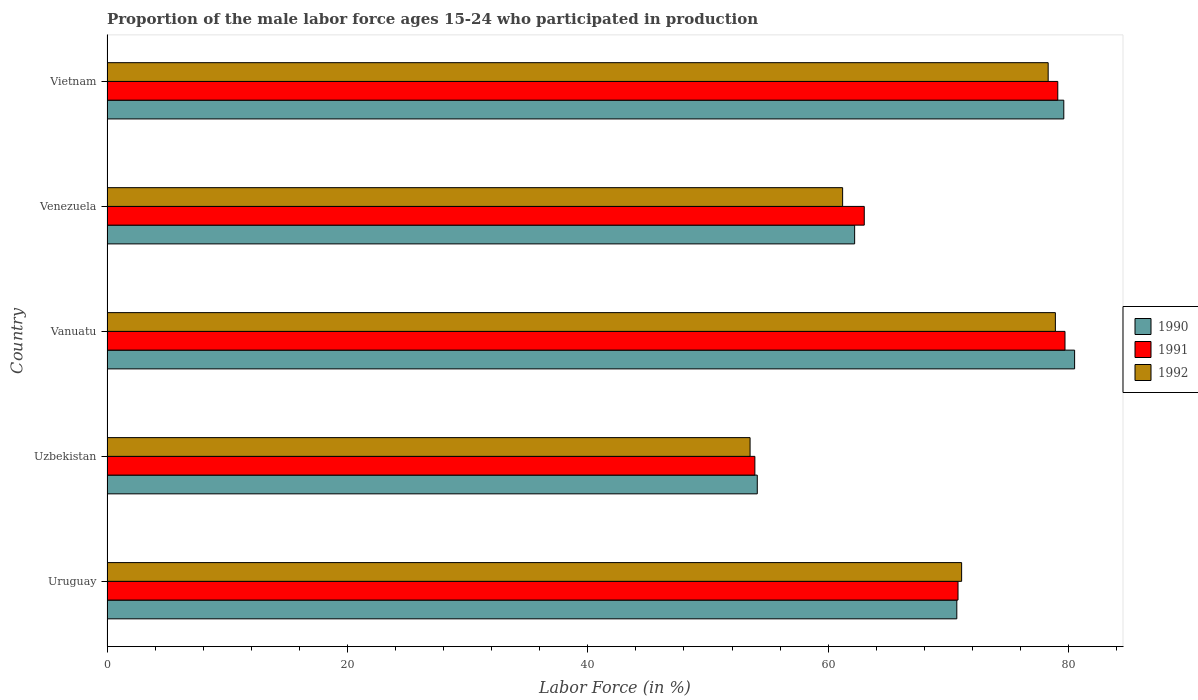Are the number of bars per tick equal to the number of legend labels?
Keep it short and to the point. Yes. Are the number of bars on each tick of the Y-axis equal?
Provide a short and direct response. Yes. How many bars are there on the 5th tick from the top?
Provide a short and direct response. 3. How many bars are there on the 2nd tick from the bottom?
Give a very brief answer. 3. What is the label of the 2nd group of bars from the top?
Ensure brevity in your answer.  Venezuela. What is the proportion of the male labor force who participated in production in 1990 in Venezuela?
Your answer should be compact. 62.2. Across all countries, what is the maximum proportion of the male labor force who participated in production in 1990?
Provide a succinct answer. 80.5. Across all countries, what is the minimum proportion of the male labor force who participated in production in 1991?
Offer a terse response. 53.9. In which country was the proportion of the male labor force who participated in production in 1992 maximum?
Provide a short and direct response. Vanuatu. In which country was the proportion of the male labor force who participated in production in 1990 minimum?
Offer a terse response. Uzbekistan. What is the total proportion of the male labor force who participated in production in 1991 in the graph?
Keep it short and to the point. 346.5. What is the difference between the proportion of the male labor force who participated in production in 1991 in Uruguay and that in Vietnam?
Give a very brief answer. -8.3. What is the difference between the proportion of the male labor force who participated in production in 1992 in Uzbekistan and the proportion of the male labor force who participated in production in 1990 in Venezuela?
Your answer should be very brief. -8.7. What is the average proportion of the male labor force who participated in production in 1991 per country?
Your answer should be compact. 69.3. What is the difference between the proportion of the male labor force who participated in production in 1991 and proportion of the male labor force who participated in production in 1992 in Uzbekistan?
Provide a succinct answer. 0.4. What is the ratio of the proportion of the male labor force who participated in production in 1992 in Vanuatu to that in Vietnam?
Your answer should be compact. 1.01. Is the proportion of the male labor force who participated in production in 1992 in Uruguay less than that in Venezuela?
Offer a very short reply. No. Is the difference between the proportion of the male labor force who participated in production in 1991 in Uruguay and Vanuatu greater than the difference between the proportion of the male labor force who participated in production in 1992 in Uruguay and Vanuatu?
Make the answer very short. No. What is the difference between the highest and the second highest proportion of the male labor force who participated in production in 1990?
Provide a short and direct response. 0.9. What is the difference between the highest and the lowest proportion of the male labor force who participated in production in 1990?
Make the answer very short. 26.4. In how many countries, is the proportion of the male labor force who participated in production in 1991 greater than the average proportion of the male labor force who participated in production in 1991 taken over all countries?
Give a very brief answer. 3. What does the 3rd bar from the top in Uruguay represents?
Your answer should be compact. 1990. What does the 1st bar from the bottom in Uzbekistan represents?
Provide a succinct answer. 1990. Is it the case that in every country, the sum of the proportion of the male labor force who participated in production in 1991 and proportion of the male labor force who participated in production in 1990 is greater than the proportion of the male labor force who participated in production in 1992?
Provide a succinct answer. Yes. What is the difference between two consecutive major ticks on the X-axis?
Offer a terse response. 20. Are the values on the major ticks of X-axis written in scientific E-notation?
Keep it short and to the point. No. How many legend labels are there?
Your answer should be compact. 3. What is the title of the graph?
Your answer should be very brief. Proportion of the male labor force ages 15-24 who participated in production. What is the label or title of the X-axis?
Offer a very short reply. Labor Force (in %). What is the label or title of the Y-axis?
Provide a succinct answer. Country. What is the Labor Force (in %) of 1990 in Uruguay?
Provide a short and direct response. 70.7. What is the Labor Force (in %) in 1991 in Uruguay?
Give a very brief answer. 70.8. What is the Labor Force (in %) of 1992 in Uruguay?
Your answer should be compact. 71.1. What is the Labor Force (in %) in 1990 in Uzbekistan?
Ensure brevity in your answer.  54.1. What is the Labor Force (in %) in 1991 in Uzbekistan?
Make the answer very short. 53.9. What is the Labor Force (in %) of 1992 in Uzbekistan?
Your answer should be very brief. 53.5. What is the Labor Force (in %) in 1990 in Vanuatu?
Provide a succinct answer. 80.5. What is the Labor Force (in %) of 1991 in Vanuatu?
Provide a succinct answer. 79.7. What is the Labor Force (in %) of 1992 in Vanuatu?
Keep it short and to the point. 78.9. What is the Labor Force (in %) in 1990 in Venezuela?
Your answer should be very brief. 62.2. What is the Labor Force (in %) in 1992 in Venezuela?
Make the answer very short. 61.2. What is the Labor Force (in %) in 1990 in Vietnam?
Give a very brief answer. 79.6. What is the Labor Force (in %) of 1991 in Vietnam?
Make the answer very short. 79.1. What is the Labor Force (in %) of 1992 in Vietnam?
Your answer should be very brief. 78.3. Across all countries, what is the maximum Labor Force (in %) of 1990?
Your answer should be compact. 80.5. Across all countries, what is the maximum Labor Force (in %) of 1991?
Your answer should be very brief. 79.7. Across all countries, what is the maximum Labor Force (in %) of 1992?
Provide a succinct answer. 78.9. Across all countries, what is the minimum Labor Force (in %) of 1990?
Make the answer very short. 54.1. Across all countries, what is the minimum Labor Force (in %) of 1991?
Make the answer very short. 53.9. Across all countries, what is the minimum Labor Force (in %) of 1992?
Ensure brevity in your answer.  53.5. What is the total Labor Force (in %) in 1990 in the graph?
Make the answer very short. 347.1. What is the total Labor Force (in %) of 1991 in the graph?
Make the answer very short. 346.5. What is the total Labor Force (in %) of 1992 in the graph?
Offer a terse response. 343. What is the difference between the Labor Force (in %) in 1991 in Uruguay and that in Uzbekistan?
Offer a terse response. 16.9. What is the difference between the Labor Force (in %) in 1992 in Uruguay and that in Uzbekistan?
Provide a short and direct response. 17.6. What is the difference between the Labor Force (in %) in 1991 in Uruguay and that in Vanuatu?
Provide a short and direct response. -8.9. What is the difference between the Labor Force (in %) of 1990 in Uruguay and that in Venezuela?
Give a very brief answer. 8.5. What is the difference between the Labor Force (in %) of 1991 in Uruguay and that in Venezuela?
Provide a succinct answer. 7.8. What is the difference between the Labor Force (in %) of 1992 in Uruguay and that in Venezuela?
Provide a short and direct response. 9.9. What is the difference between the Labor Force (in %) in 1992 in Uruguay and that in Vietnam?
Your answer should be compact. -7.2. What is the difference between the Labor Force (in %) in 1990 in Uzbekistan and that in Vanuatu?
Your answer should be very brief. -26.4. What is the difference between the Labor Force (in %) in 1991 in Uzbekistan and that in Vanuatu?
Keep it short and to the point. -25.8. What is the difference between the Labor Force (in %) in 1992 in Uzbekistan and that in Vanuatu?
Your answer should be very brief. -25.4. What is the difference between the Labor Force (in %) of 1990 in Uzbekistan and that in Venezuela?
Your answer should be very brief. -8.1. What is the difference between the Labor Force (in %) of 1992 in Uzbekistan and that in Venezuela?
Offer a very short reply. -7.7. What is the difference between the Labor Force (in %) of 1990 in Uzbekistan and that in Vietnam?
Offer a very short reply. -25.5. What is the difference between the Labor Force (in %) in 1991 in Uzbekistan and that in Vietnam?
Your answer should be very brief. -25.2. What is the difference between the Labor Force (in %) in 1992 in Uzbekistan and that in Vietnam?
Offer a terse response. -24.8. What is the difference between the Labor Force (in %) of 1990 in Vanuatu and that in Venezuela?
Your response must be concise. 18.3. What is the difference between the Labor Force (in %) of 1992 in Vanuatu and that in Vietnam?
Ensure brevity in your answer.  0.6. What is the difference between the Labor Force (in %) of 1990 in Venezuela and that in Vietnam?
Provide a succinct answer. -17.4. What is the difference between the Labor Force (in %) of 1991 in Venezuela and that in Vietnam?
Make the answer very short. -16.1. What is the difference between the Labor Force (in %) in 1992 in Venezuela and that in Vietnam?
Your answer should be compact. -17.1. What is the difference between the Labor Force (in %) of 1990 in Uruguay and the Labor Force (in %) of 1991 in Uzbekistan?
Give a very brief answer. 16.8. What is the difference between the Labor Force (in %) in 1990 in Uruguay and the Labor Force (in %) in 1992 in Uzbekistan?
Keep it short and to the point. 17.2. What is the difference between the Labor Force (in %) of 1991 in Uruguay and the Labor Force (in %) of 1992 in Uzbekistan?
Give a very brief answer. 17.3. What is the difference between the Labor Force (in %) of 1990 in Uruguay and the Labor Force (in %) of 1992 in Vanuatu?
Offer a very short reply. -8.2. What is the difference between the Labor Force (in %) in 1991 in Uruguay and the Labor Force (in %) in 1992 in Vanuatu?
Your answer should be very brief. -8.1. What is the difference between the Labor Force (in %) in 1991 in Uruguay and the Labor Force (in %) in 1992 in Venezuela?
Your response must be concise. 9.6. What is the difference between the Labor Force (in %) of 1990 in Uruguay and the Labor Force (in %) of 1991 in Vietnam?
Ensure brevity in your answer.  -8.4. What is the difference between the Labor Force (in %) of 1990 in Uruguay and the Labor Force (in %) of 1992 in Vietnam?
Your answer should be very brief. -7.6. What is the difference between the Labor Force (in %) of 1990 in Uzbekistan and the Labor Force (in %) of 1991 in Vanuatu?
Give a very brief answer. -25.6. What is the difference between the Labor Force (in %) of 1990 in Uzbekistan and the Labor Force (in %) of 1992 in Vanuatu?
Keep it short and to the point. -24.8. What is the difference between the Labor Force (in %) in 1990 in Uzbekistan and the Labor Force (in %) in 1991 in Venezuela?
Your response must be concise. -8.9. What is the difference between the Labor Force (in %) in 1990 in Uzbekistan and the Labor Force (in %) in 1992 in Venezuela?
Provide a succinct answer. -7.1. What is the difference between the Labor Force (in %) in 1990 in Uzbekistan and the Labor Force (in %) in 1991 in Vietnam?
Give a very brief answer. -25. What is the difference between the Labor Force (in %) in 1990 in Uzbekistan and the Labor Force (in %) in 1992 in Vietnam?
Keep it short and to the point. -24.2. What is the difference between the Labor Force (in %) of 1991 in Uzbekistan and the Labor Force (in %) of 1992 in Vietnam?
Your answer should be very brief. -24.4. What is the difference between the Labor Force (in %) in 1990 in Vanuatu and the Labor Force (in %) in 1992 in Venezuela?
Provide a succinct answer. 19.3. What is the difference between the Labor Force (in %) in 1990 in Vanuatu and the Labor Force (in %) in 1991 in Vietnam?
Keep it short and to the point. 1.4. What is the difference between the Labor Force (in %) in 1990 in Vanuatu and the Labor Force (in %) in 1992 in Vietnam?
Your answer should be very brief. 2.2. What is the difference between the Labor Force (in %) in 1990 in Venezuela and the Labor Force (in %) in 1991 in Vietnam?
Your answer should be compact. -16.9. What is the difference between the Labor Force (in %) of 1990 in Venezuela and the Labor Force (in %) of 1992 in Vietnam?
Offer a terse response. -16.1. What is the difference between the Labor Force (in %) of 1991 in Venezuela and the Labor Force (in %) of 1992 in Vietnam?
Provide a succinct answer. -15.3. What is the average Labor Force (in %) of 1990 per country?
Provide a succinct answer. 69.42. What is the average Labor Force (in %) of 1991 per country?
Provide a short and direct response. 69.3. What is the average Labor Force (in %) in 1992 per country?
Provide a succinct answer. 68.6. What is the difference between the Labor Force (in %) of 1990 and Labor Force (in %) of 1992 in Uruguay?
Make the answer very short. -0.4. What is the difference between the Labor Force (in %) in 1990 and Labor Force (in %) in 1991 in Uzbekistan?
Ensure brevity in your answer.  0.2. What is the difference between the Labor Force (in %) in 1991 and Labor Force (in %) in 1992 in Uzbekistan?
Give a very brief answer. 0.4. What is the difference between the Labor Force (in %) of 1990 and Labor Force (in %) of 1992 in Vanuatu?
Your answer should be compact. 1.6. What is the difference between the Labor Force (in %) in 1991 and Labor Force (in %) in 1992 in Vanuatu?
Provide a short and direct response. 0.8. What is the difference between the Labor Force (in %) in 1990 and Labor Force (in %) in 1991 in Venezuela?
Give a very brief answer. -0.8. What is the difference between the Labor Force (in %) in 1990 and Labor Force (in %) in 1992 in Venezuela?
Your answer should be very brief. 1. What is the difference between the Labor Force (in %) of 1990 and Labor Force (in %) of 1991 in Vietnam?
Keep it short and to the point. 0.5. What is the difference between the Labor Force (in %) in 1991 and Labor Force (in %) in 1992 in Vietnam?
Offer a terse response. 0.8. What is the ratio of the Labor Force (in %) of 1990 in Uruguay to that in Uzbekistan?
Keep it short and to the point. 1.31. What is the ratio of the Labor Force (in %) of 1991 in Uruguay to that in Uzbekistan?
Your response must be concise. 1.31. What is the ratio of the Labor Force (in %) in 1992 in Uruguay to that in Uzbekistan?
Provide a succinct answer. 1.33. What is the ratio of the Labor Force (in %) of 1990 in Uruguay to that in Vanuatu?
Your answer should be very brief. 0.88. What is the ratio of the Labor Force (in %) in 1991 in Uruguay to that in Vanuatu?
Your response must be concise. 0.89. What is the ratio of the Labor Force (in %) in 1992 in Uruguay to that in Vanuatu?
Give a very brief answer. 0.9. What is the ratio of the Labor Force (in %) of 1990 in Uruguay to that in Venezuela?
Keep it short and to the point. 1.14. What is the ratio of the Labor Force (in %) in 1991 in Uruguay to that in Venezuela?
Provide a short and direct response. 1.12. What is the ratio of the Labor Force (in %) of 1992 in Uruguay to that in Venezuela?
Your response must be concise. 1.16. What is the ratio of the Labor Force (in %) in 1990 in Uruguay to that in Vietnam?
Ensure brevity in your answer.  0.89. What is the ratio of the Labor Force (in %) in 1991 in Uruguay to that in Vietnam?
Your answer should be very brief. 0.9. What is the ratio of the Labor Force (in %) of 1992 in Uruguay to that in Vietnam?
Your response must be concise. 0.91. What is the ratio of the Labor Force (in %) of 1990 in Uzbekistan to that in Vanuatu?
Your response must be concise. 0.67. What is the ratio of the Labor Force (in %) in 1991 in Uzbekistan to that in Vanuatu?
Your answer should be very brief. 0.68. What is the ratio of the Labor Force (in %) in 1992 in Uzbekistan to that in Vanuatu?
Provide a succinct answer. 0.68. What is the ratio of the Labor Force (in %) in 1990 in Uzbekistan to that in Venezuela?
Your answer should be very brief. 0.87. What is the ratio of the Labor Force (in %) in 1991 in Uzbekistan to that in Venezuela?
Provide a succinct answer. 0.86. What is the ratio of the Labor Force (in %) of 1992 in Uzbekistan to that in Venezuela?
Ensure brevity in your answer.  0.87. What is the ratio of the Labor Force (in %) of 1990 in Uzbekistan to that in Vietnam?
Keep it short and to the point. 0.68. What is the ratio of the Labor Force (in %) of 1991 in Uzbekistan to that in Vietnam?
Keep it short and to the point. 0.68. What is the ratio of the Labor Force (in %) in 1992 in Uzbekistan to that in Vietnam?
Your response must be concise. 0.68. What is the ratio of the Labor Force (in %) of 1990 in Vanuatu to that in Venezuela?
Your answer should be compact. 1.29. What is the ratio of the Labor Force (in %) of 1991 in Vanuatu to that in Venezuela?
Keep it short and to the point. 1.27. What is the ratio of the Labor Force (in %) in 1992 in Vanuatu to that in Venezuela?
Ensure brevity in your answer.  1.29. What is the ratio of the Labor Force (in %) of 1990 in Vanuatu to that in Vietnam?
Ensure brevity in your answer.  1.01. What is the ratio of the Labor Force (in %) of 1991 in Vanuatu to that in Vietnam?
Your answer should be compact. 1.01. What is the ratio of the Labor Force (in %) in 1992 in Vanuatu to that in Vietnam?
Your response must be concise. 1.01. What is the ratio of the Labor Force (in %) of 1990 in Venezuela to that in Vietnam?
Offer a terse response. 0.78. What is the ratio of the Labor Force (in %) in 1991 in Venezuela to that in Vietnam?
Provide a succinct answer. 0.8. What is the ratio of the Labor Force (in %) in 1992 in Venezuela to that in Vietnam?
Make the answer very short. 0.78. What is the difference between the highest and the second highest Labor Force (in %) of 1991?
Keep it short and to the point. 0.6. What is the difference between the highest and the lowest Labor Force (in %) in 1990?
Your answer should be compact. 26.4. What is the difference between the highest and the lowest Labor Force (in %) in 1991?
Provide a short and direct response. 25.8. What is the difference between the highest and the lowest Labor Force (in %) of 1992?
Your response must be concise. 25.4. 